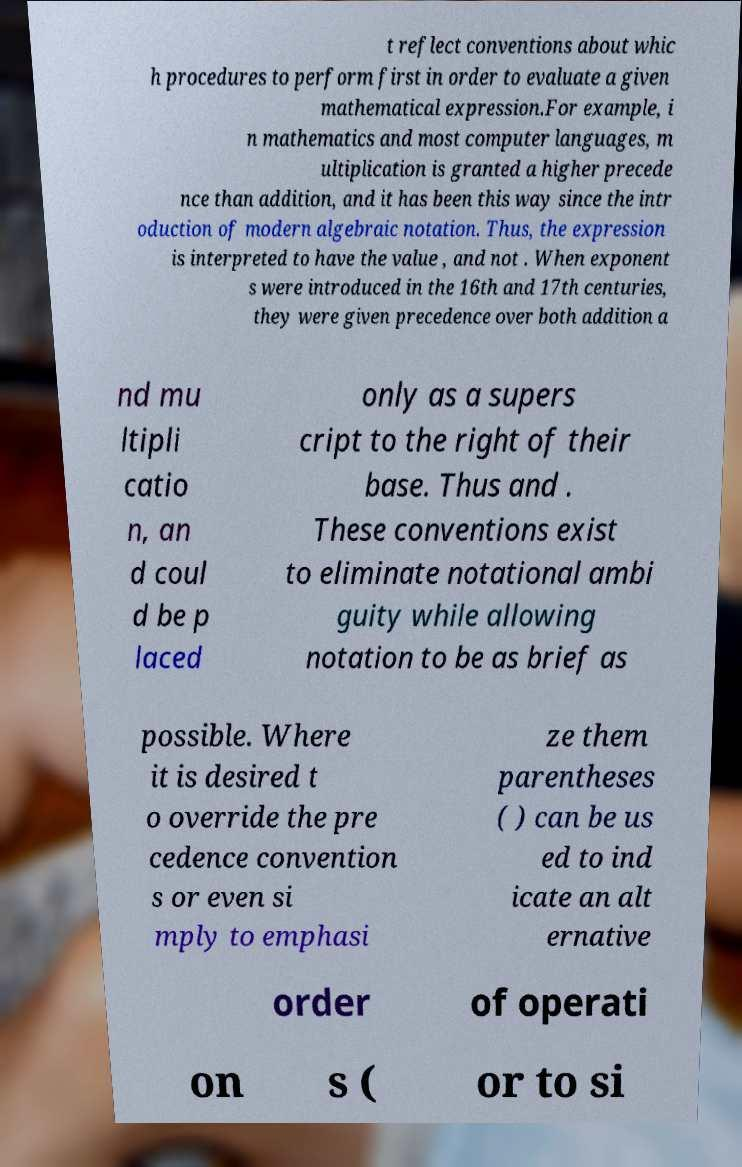Can you accurately transcribe the text from the provided image for me? t reflect conventions about whic h procedures to perform first in order to evaluate a given mathematical expression.For example, i n mathematics and most computer languages, m ultiplication is granted a higher precede nce than addition, and it has been this way since the intr oduction of modern algebraic notation. Thus, the expression is interpreted to have the value , and not . When exponent s were introduced in the 16th and 17th centuries, they were given precedence over both addition a nd mu ltipli catio n, an d coul d be p laced only as a supers cript to the right of their base. Thus and . These conventions exist to eliminate notational ambi guity while allowing notation to be as brief as possible. Where it is desired t o override the pre cedence convention s or even si mply to emphasi ze them parentheses ( ) can be us ed to ind icate an alt ernative order of operati on s ( or to si 